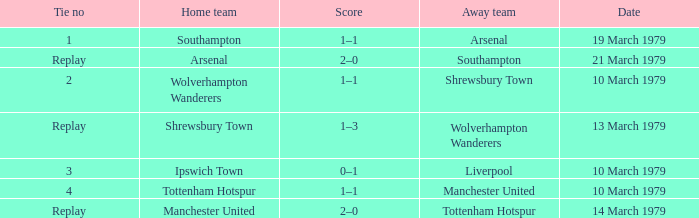What was the score for the tie that had Shrewsbury Town as home team? 1–3. 